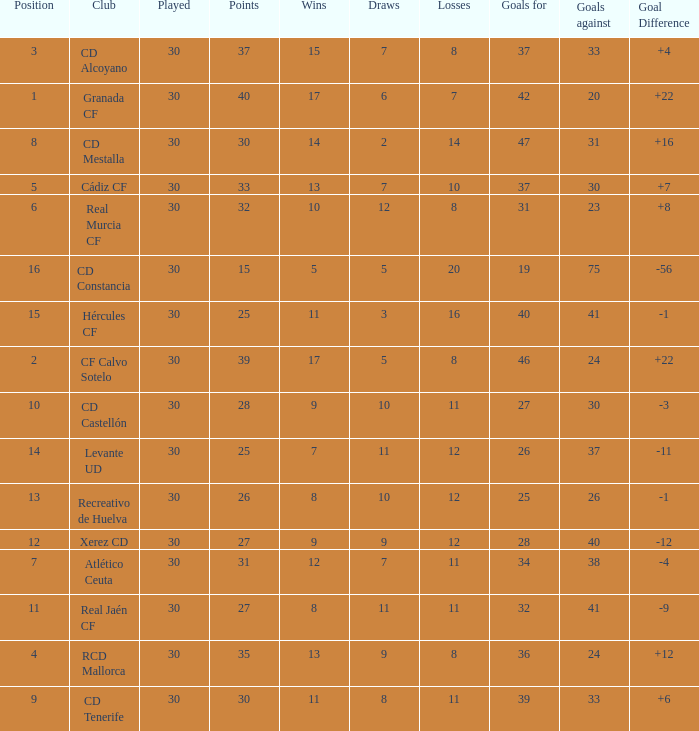How many Draws have 30 Points, and less than 33 Goals against? 1.0. 